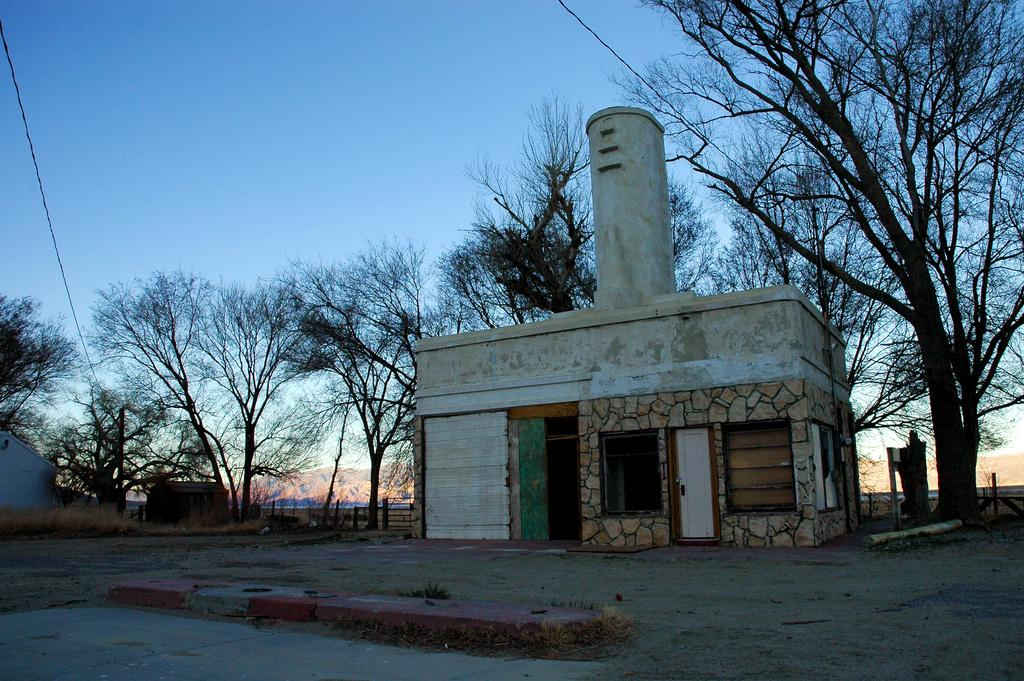What type of structures can be seen in the image? There are buildings in the image. What other natural elements are present in the image? There are trees in the image. How would you describe the ground in the image? The ground is covered with dry plants. What is the condition of the sky in the image? The sky is clear in the image. What year did the achiever toad win the prestigious award in the image? There is no achiever toad or award present in the image. 